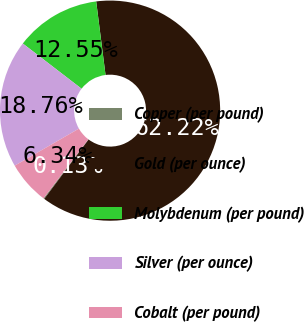Convert chart to OTSL. <chart><loc_0><loc_0><loc_500><loc_500><pie_chart><fcel>Copper (per pound)<fcel>Gold (per ounce)<fcel>Molybdenum (per pound)<fcel>Silver (per ounce)<fcel>Cobalt (per pound)<nl><fcel>0.13%<fcel>62.21%<fcel>12.55%<fcel>18.76%<fcel>6.34%<nl></chart> 